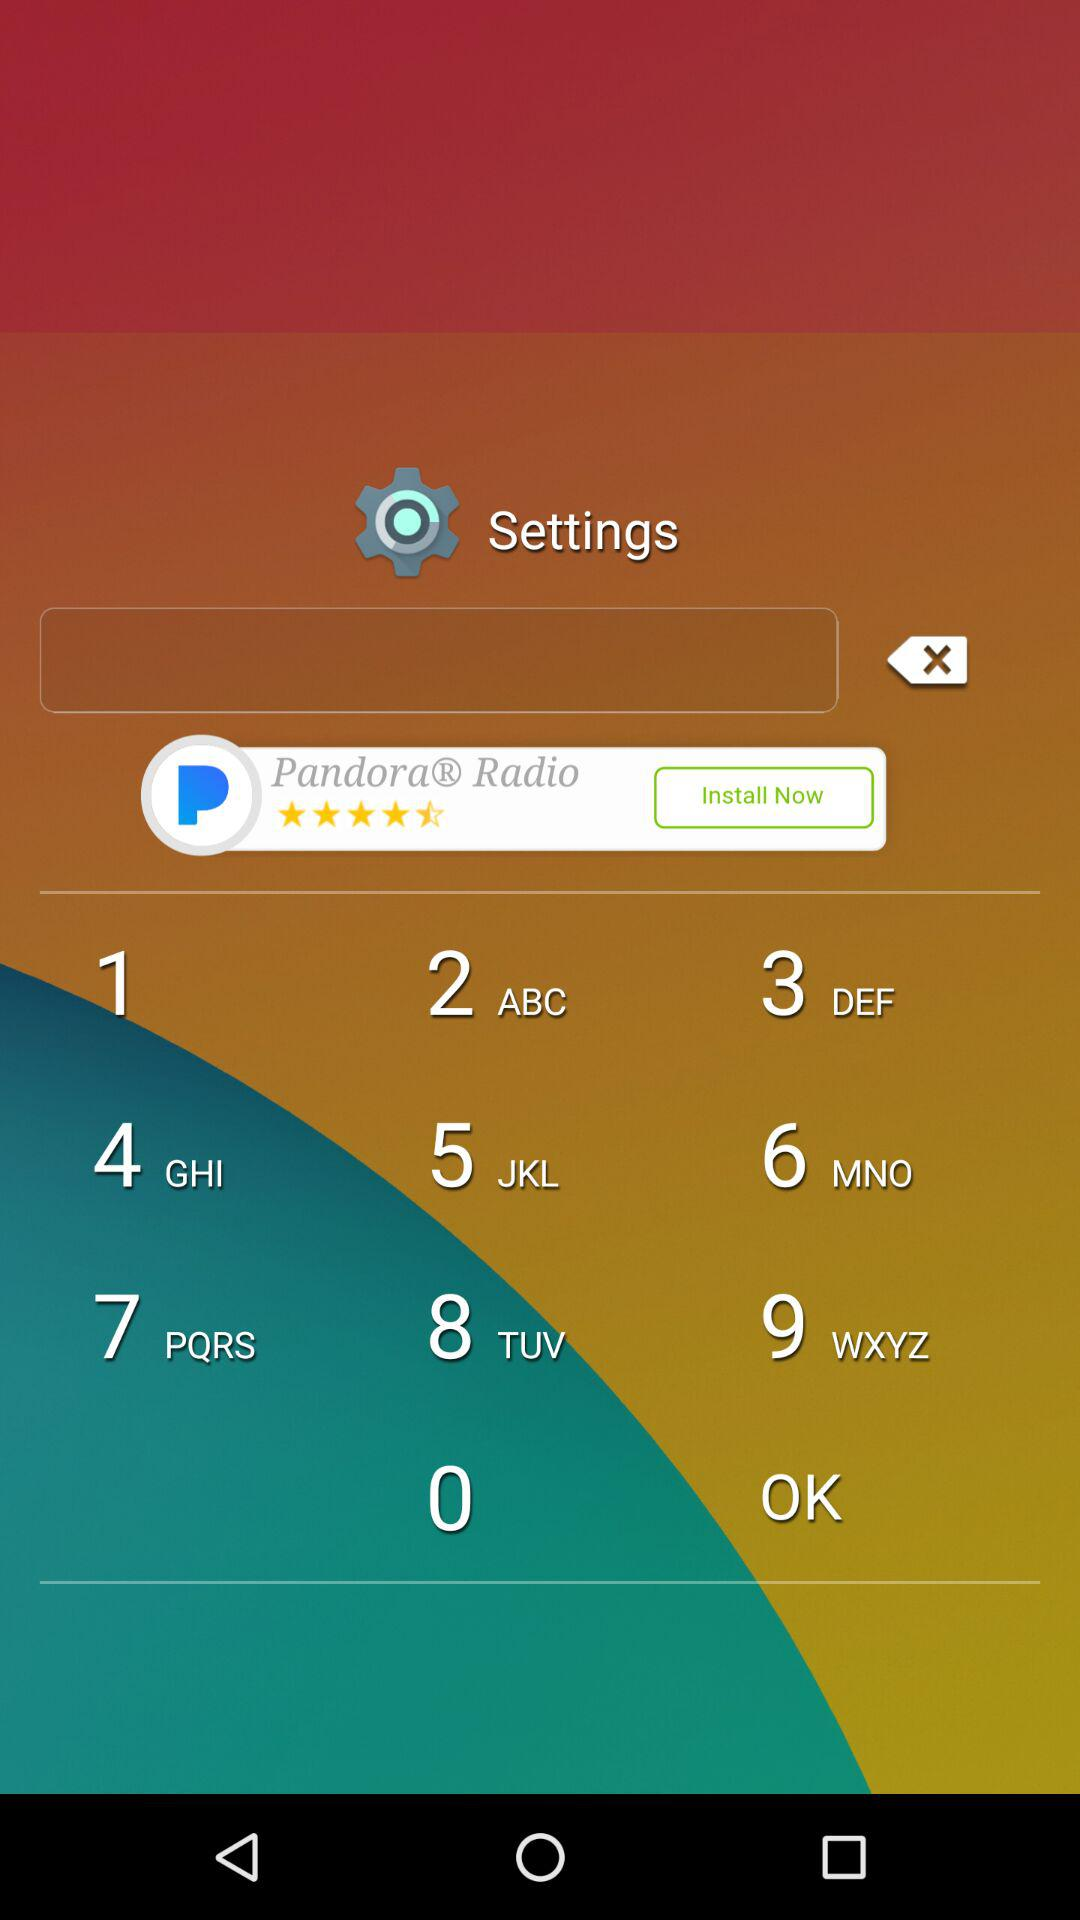How many more downloads does the app have than the number of reviews?
Answer the question using a single word or phrase. 69 million 